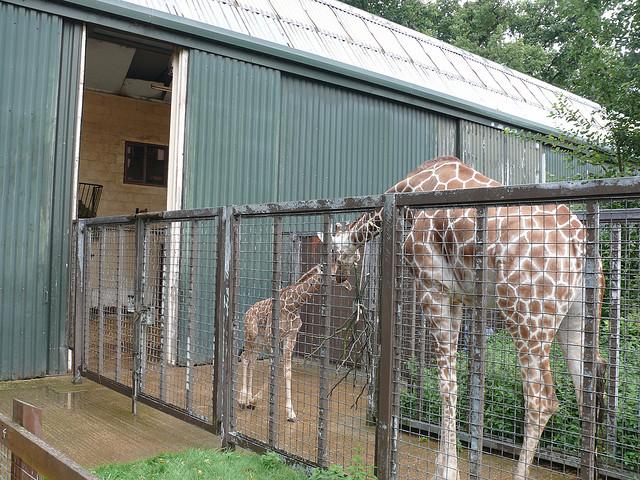Is there a baby giraffe in this picture?
Give a very brief answer. Yes. Are the giraffes in the wild?
Concise answer only. No. Is the older giraffe standing up straight?
Be succinct. No. 